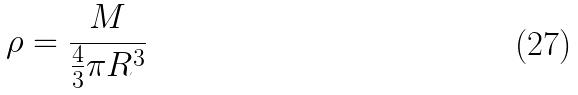Convert formula to latex. <formula><loc_0><loc_0><loc_500><loc_500>\rho = \frac { M } { \frac { 4 } { 3 } \pi R ^ { 3 } }</formula> 